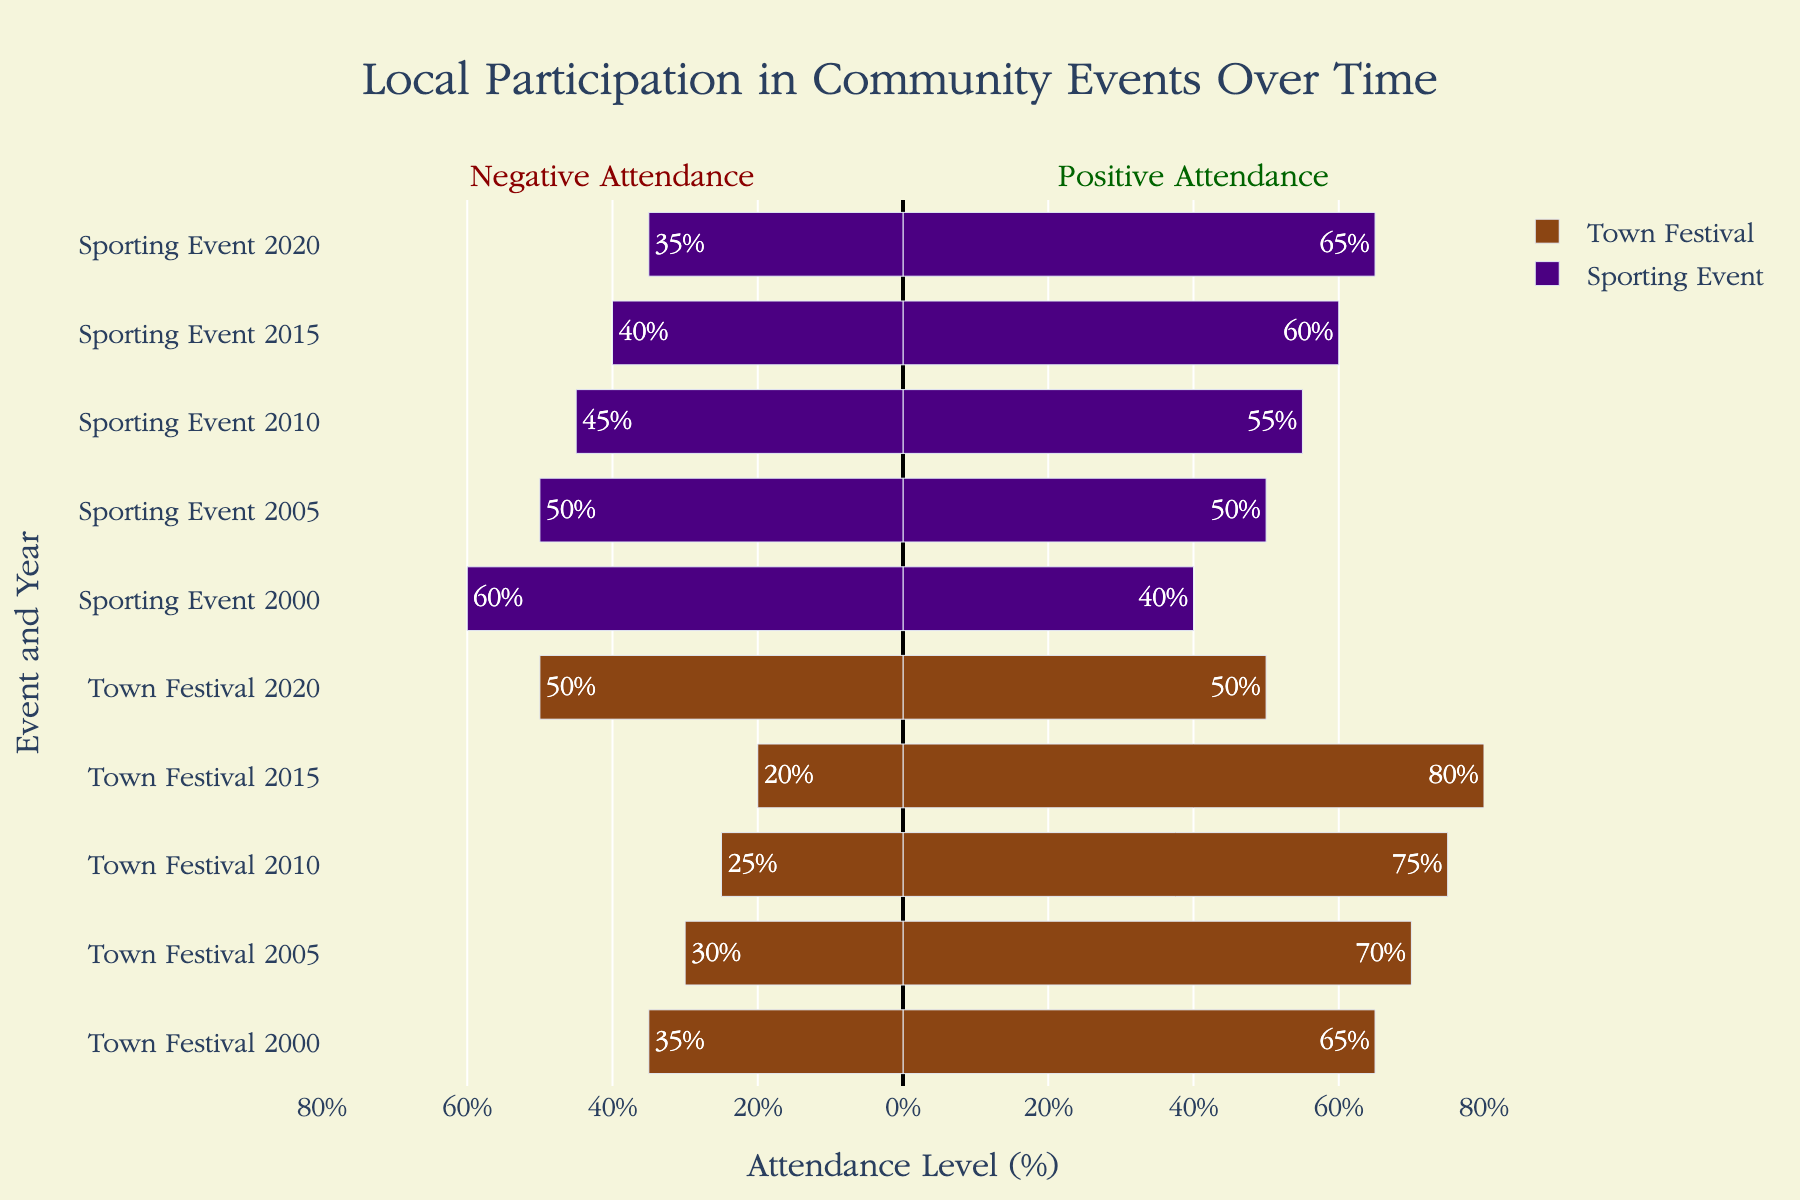What's the total positive attendance at Town Festivals from 2000 to 2020? Add the positive attendance levels for Town Festivals over all years: 65 (2000) + 70 (2005) + 75 (2010) + 80 (2015) + 50 (2020). This results in a total of 340.
Answer: 340 How did the attendance levels at Town Festivals change from 2000 to 2020? Compare the positive and negative attendance levels in the years 2000 and 2020 for Town Festivals. In 2000, positive attendance is 65% and negative is 35%. In 2020, positive attendance is 50% and negative is 50%. This shows a decrease in positive attendance and an increase in negative attendance.
Answer: Positive attendance decreased, negative attendance increased Which had greater positive attendance in 2020, Town Festivals or Sporting Events? Refer to the attendance levels for 2020. Town Festivals had 50% positive attendance, while Sporting Events had 65% positive attendance.
Answer: Sporting Events Which year had the highest positive attendance for Town Festivals between 2000 and 2020? Compare the positive attendance levels for each year in the Town Festival category: 65% (2000), 70% (2005), 75% (2010), 80% (2015), and 50% (2020). 2015 had the highest positive attendance at 80%.
Answer: 2015 In which event and year was the negative attendance level the highest? Compare the negative attendance levels for all events and years. The highest negative attendance is 60% for Sporting Events in 2000.
Answer: Sporting Events, 2000 What is the average positive attendance level for Sporting Events from 2000 to 2020? Calculate the sum of positive attendance levels for Sporting Events over all years and divide by the number of years: (40 + 50 + 55 + 60 + 65) / 5 = 270 / 5 = 54.
Answer: 54 Between 2015 and 2020, did Sporting Events see an increase or decrease in negative attendance? Compare negative attendance levels of Sporting Events in 2015 (40%) and 2020 (35%). Negative attendance decreased from 40% to 35%.
Answer: Decrease How do the colors of the bars help in distinguishing between Town Festivals and Sporting Events in the chart? Identify the colors used in the chart. Town Festival bars are brown, and Sporting Event bars are purple. The distinct colors make it easier to differentiate between the two events.
Answer: Brown for Town Festivals, purple for Sporting Events Which event saw a greater decline in positive attendance from its highest level to 2020? Refer to the highest positive attendance and 2020 positive attendance for both events. Town Festivals saw a decline from 80% in 2015 to 50% in 2020 (a decline of 30%). Sporting Events saw a decline from 65% in 2020 but had no higher level before 2020. Thus, Town Festivals had a greater decline.
Answer: Town Festivals 